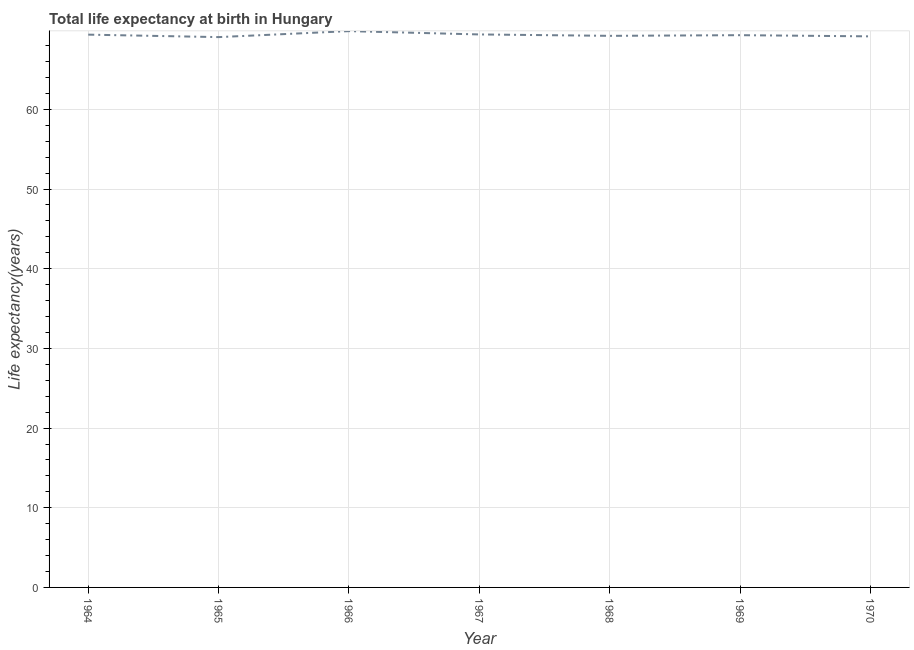What is the life expectancy at birth in 1969?
Provide a succinct answer. 69.31. Across all years, what is the maximum life expectancy at birth?
Your answer should be very brief. 69.82. Across all years, what is the minimum life expectancy at birth?
Provide a short and direct response. 69.07. In which year was the life expectancy at birth maximum?
Offer a very short reply. 1966. In which year was the life expectancy at birth minimum?
Make the answer very short. 1965. What is the sum of the life expectancy at birth?
Ensure brevity in your answer.  485.39. What is the difference between the life expectancy at birth in 1964 and 1967?
Make the answer very short. -0.03. What is the average life expectancy at birth per year?
Your answer should be very brief. 69.34. What is the median life expectancy at birth?
Your answer should be compact. 69.31. Do a majority of the years between 1967 and 1964 (inclusive) have life expectancy at birth greater than 60 years?
Offer a terse response. Yes. What is the ratio of the life expectancy at birth in 1966 to that in 1967?
Your response must be concise. 1.01. What is the difference between the highest and the second highest life expectancy at birth?
Your answer should be compact. 0.42. What is the difference between the highest and the lowest life expectancy at birth?
Keep it short and to the point. 0.75. In how many years, is the life expectancy at birth greater than the average life expectancy at birth taken over all years?
Offer a terse response. 3. Does the life expectancy at birth monotonically increase over the years?
Offer a terse response. No. How many lines are there?
Offer a terse response. 1. What is the difference between two consecutive major ticks on the Y-axis?
Your response must be concise. 10. Are the values on the major ticks of Y-axis written in scientific E-notation?
Give a very brief answer. No. Does the graph contain grids?
Give a very brief answer. Yes. What is the title of the graph?
Provide a succinct answer. Total life expectancy at birth in Hungary. What is the label or title of the X-axis?
Your answer should be compact. Year. What is the label or title of the Y-axis?
Offer a very short reply. Life expectancy(years). What is the Life expectancy(years) of 1964?
Ensure brevity in your answer.  69.38. What is the Life expectancy(years) in 1965?
Provide a short and direct response. 69.07. What is the Life expectancy(years) of 1966?
Offer a terse response. 69.82. What is the Life expectancy(years) in 1967?
Provide a succinct answer. 69.41. What is the Life expectancy(years) of 1968?
Provide a short and direct response. 69.23. What is the Life expectancy(years) in 1969?
Offer a terse response. 69.31. What is the Life expectancy(years) of 1970?
Make the answer very short. 69.16. What is the difference between the Life expectancy(years) in 1964 and 1965?
Your answer should be very brief. 0.31. What is the difference between the Life expectancy(years) in 1964 and 1966?
Your response must be concise. -0.44. What is the difference between the Life expectancy(years) in 1964 and 1967?
Provide a succinct answer. -0.03. What is the difference between the Life expectancy(years) in 1964 and 1968?
Offer a very short reply. 0.15. What is the difference between the Life expectancy(years) in 1964 and 1969?
Provide a short and direct response. 0.07. What is the difference between the Life expectancy(years) in 1964 and 1970?
Make the answer very short. 0.22. What is the difference between the Life expectancy(years) in 1965 and 1966?
Give a very brief answer. -0.75. What is the difference between the Life expectancy(years) in 1965 and 1967?
Provide a short and direct response. -0.34. What is the difference between the Life expectancy(years) in 1965 and 1968?
Offer a terse response. -0.16. What is the difference between the Life expectancy(years) in 1965 and 1969?
Make the answer very short. -0.24. What is the difference between the Life expectancy(years) in 1965 and 1970?
Your answer should be very brief. -0.09. What is the difference between the Life expectancy(years) in 1966 and 1967?
Make the answer very short. 0.42. What is the difference between the Life expectancy(years) in 1966 and 1968?
Provide a short and direct response. 0.59. What is the difference between the Life expectancy(years) in 1966 and 1969?
Offer a very short reply. 0.51. What is the difference between the Life expectancy(years) in 1966 and 1970?
Ensure brevity in your answer.  0.66. What is the difference between the Life expectancy(years) in 1967 and 1968?
Make the answer very short. 0.18. What is the difference between the Life expectancy(years) in 1967 and 1969?
Your answer should be very brief. 0.09. What is the difference between the Life expectancy(years) in 1967 and 1970?
Provide a short and direct response. 0.24. What is the difference between the Life expectancy(years) in 1968 and 1969?
Your answer should be compact. -0.08. What is the difference between the Life expectancy(years) in 1968 and 1970?
Your response must be concise. 0.07. What is the difference between the Life expectancy(years) in 1969 and 1970?
Give a very brief answer. 0.15. What is the ratio of the Life expectancy(years) in 1964 to that in 1965?
Your answer should be compact. 1. What is the ratio of the Life expectancy(years) in 1964 to that in 1967?
Your answer should be compact. 1. What is the ratio of the Life expectancy(years) in 1964 to that in 1970?
Keep it short and to the point. 1. What is the ratio of the Life expectancy(years) in 1965 to that in 1967?
Offer a very short reply. 0.99. What is the ratio of the Life expectancy(years) in 1965 to that in 1968?
Your answer should be compact. 1. What is the ratio of the Life expectancy(years) in 1965 to that in 1969?
Your response must be concise. 1. What is the ratio of the Life expectancy(years) in 1965 to that in 1970?
Your response must be concise. 1. What is the ratio of the Life expectancy(years) in 1966 to that in 1968?
Offer a terse response. 1.01. What is the ratio of the Life expectancy(years) in 1966 to that in 1970?
Your response must be concise. 1.01. What is the ratio of the Life expectancy(years) in 1967 to that in 1968?
Make the answer very short. 1. What is the ratio of the Life expectancy(years) in 1967 to that in 1970?
Keep it short and to the point. 1. What is the ratio of the Life expectancy(years) in 1968 to that in 1969?
Your response must be concise. 1. What is the ratio of the Life expectancy(years) in 1968 to that in 1970?
Offer a very short reply. 1. What is the ratio of the Life expectancy(years) in 1969 to that in 1970?
Provide a succinct answer. 1. 